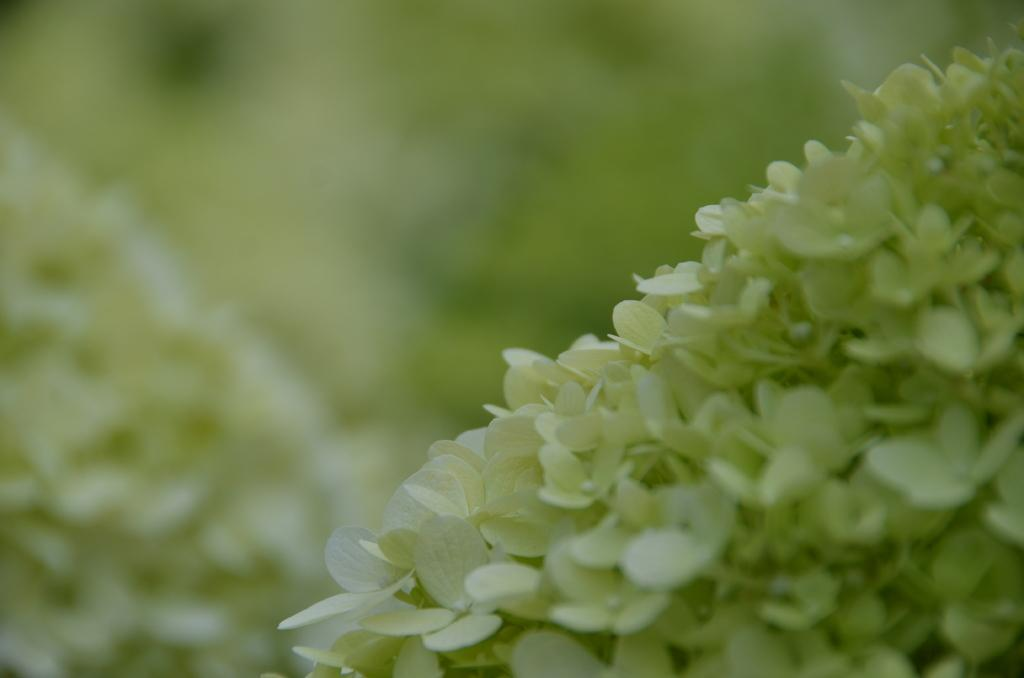What type of flowers are in the image? There are white color flowers in the image. Can you describe the background of the image? The background of the image is blurred. How many fingers can be seen on the insect in the image? There are no insects present in the image, and therefore no fingers can be observed. What type of fight is taking place in the image? There is no fight present in the image; it features white color flowers and a blurred background. 